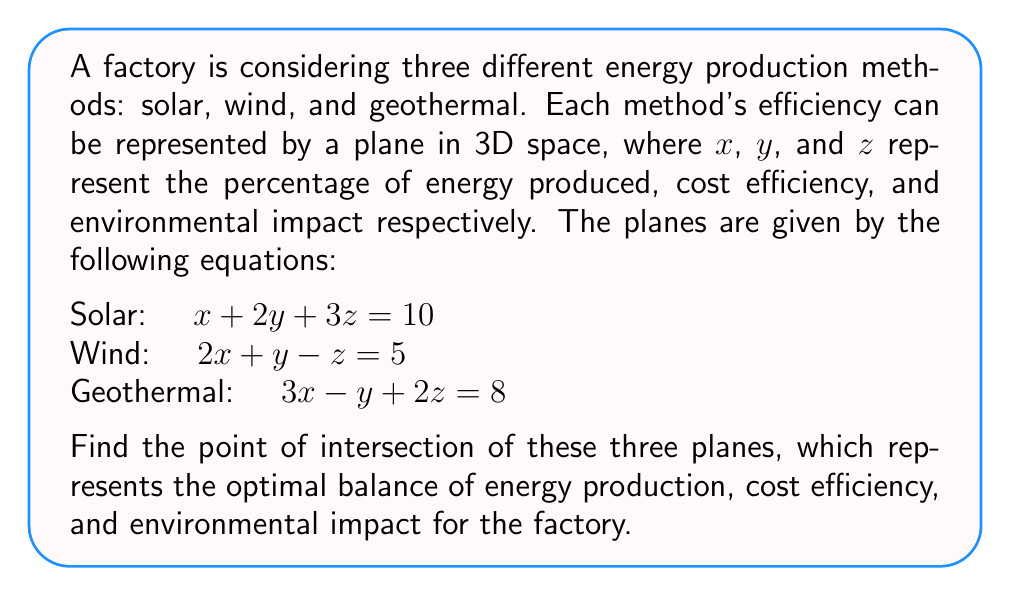Help me with this question. To find the point of intersection of the three planes, we need to solve the system of linear equations:

$$ \begin{cases}
x + 2y + 3z = 10 \\
2x + y - z = 5 \\
3x - y + 2z = 8
\end{cases} $$

Let's solve this system using the elimination method:

1) Multiply the first equation by 2 and subtract it from the second equation:
   $$ 2(x + 2y + 3z = 10) \implies 2x + 4y + 6z = 20 $$
   $$ (2x + y - z = 5) - (2x + 4y + 6z = 20) $$
   $$ -3y - 7z = -15 \quad (1) $$

2) Multiply the first equation by 3 and subtract it from the third equation:
   $$ 3(x + 2y + 3z = 10) \implies 3x + 6y + 9z = 30 $$
   $$ (3x - y + 2z = 8) - (3x + 6y + 9z = 30) $$
   $$ -7y - 7z = -22 \quad (2) $$

3) Subtract equation (1) from equation (2):
   $$ (-7y - 7z = -22) - (-3y - 7z = -15) $$
   $$ -4y = -7 $$
   $$ y = \frac{7}{4} $$

4) Substitute y into equation (1):
   $$ -3(\frac{7}{4}) - 7z = -15 $$
   $$ -\frac{21}{4} - 7z = -15 $$
   $$ -7z = -15 + \frac{21}{4} = -\frac{39}{4} $$
   $$ z = \frac{39}{28} $$

5) Substitute y and z into the first original equation:
   $$ x + 2(\frac{7}{4}) + 3(\frac{39}{28}) = 10 $$
   $$ x + \frac{7}{2} + \frac{117}{28} = 10 $$
   $$ x = 10 - \frac{7}{2} - \frac{117}{28} = \frac{280}{28} - \frac{98}{28} - \frac{117}{28} = \frac{65}{28} $$

Therefore, the point of intersection is $(\frac{65}{28}, \frac{7}{4}, \frac{39}{28})$.
Answer: $(\frac{65}{28}, \frac{7}{4}, \frac{39}{28})$ 